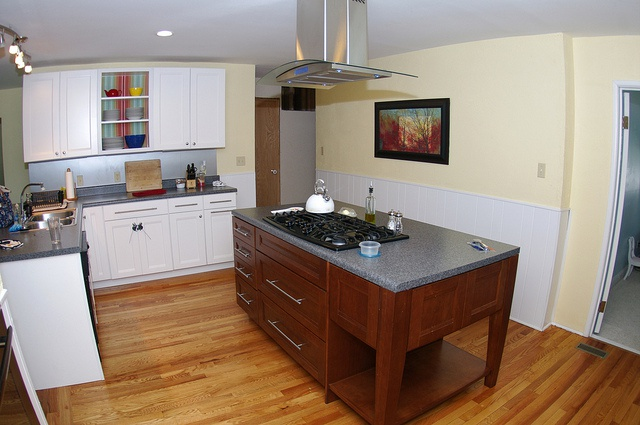Describe the objects in this image and their specific colors. I can see sink in darkgray, gray, and black tones, bottle in darkgray, gray, and black tones, chair in darkgray, gray, black, and teal tones, cup in darkgray and gray tones, and cup in darkgray and gray tones in this image. 